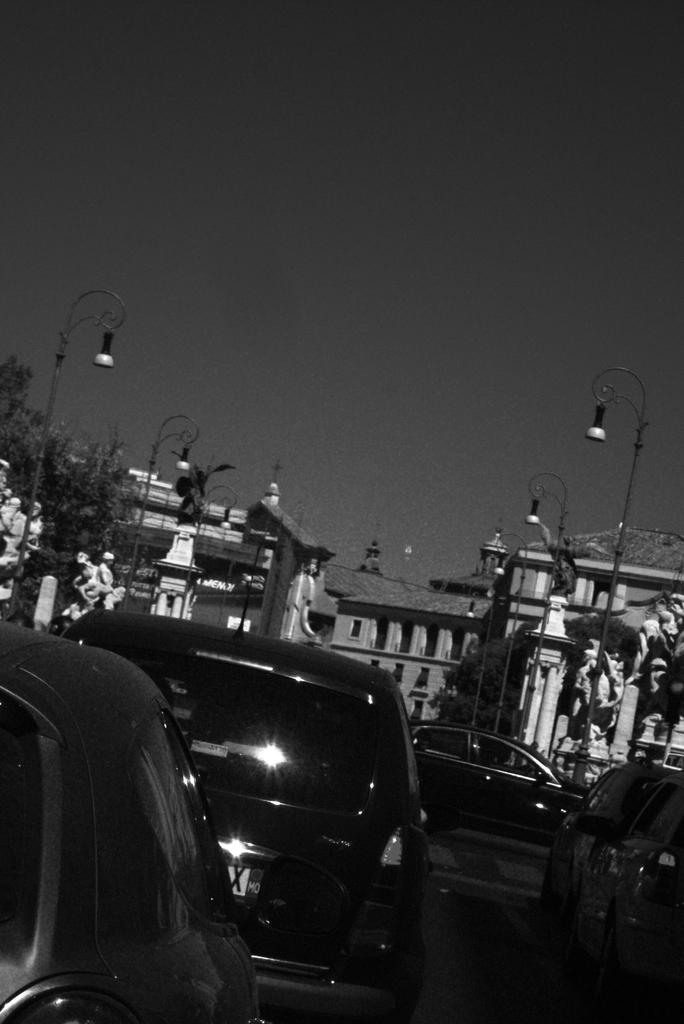What is happening on the left side of the image? There are vehicles moving on the road on the left side of the image. What can be seen in the middle of the image? There are buildings in the middle of the image. What is visible at the top of the image? The sky is visible at the top of the image. What time of day is depicted in the image? The image is set during nighttime. Is there a spy observing the vehicles on the left side of the image? There is no indication of a spy in the image; it simply shows vehicles moving on the road. What rule governs the movement of the vehicles in the image? The image does not provide information about any specific rules governing the movement of the vehicles. 